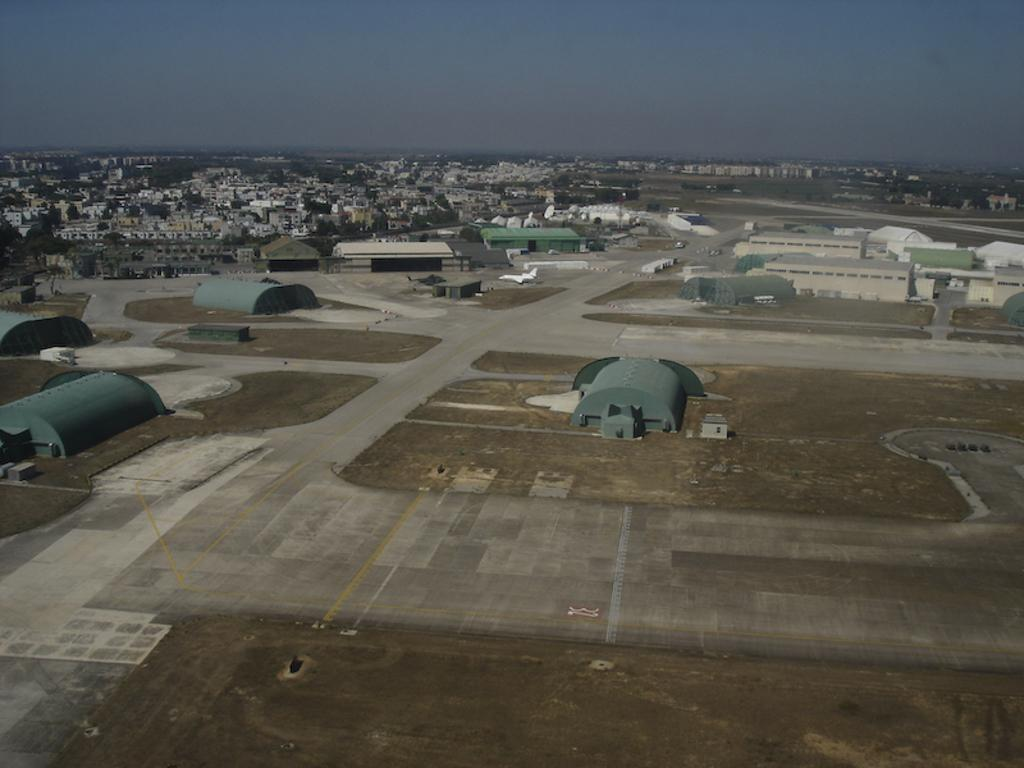What type of view is shown in the image? The image is an aerial view. What structures can be seen in the image? There are buildings and sheds in the image. What is the purpose of the airplane in the image? The airplane is likely used for transportation, as it is located near a runway. What type of transportation infrastructure is present in the image? There is a runway and roads in the image. What type of natural environment is visible in the image? There is grass, trees, and the sky visible in the image. What is the weather like in the image? The presence of clouds in the sky suggests that it might be partly cloudy. Where is the lake located in the image? There is no lake present in the image. What type of wave is visible in the image? There are no waves visible in the image. 